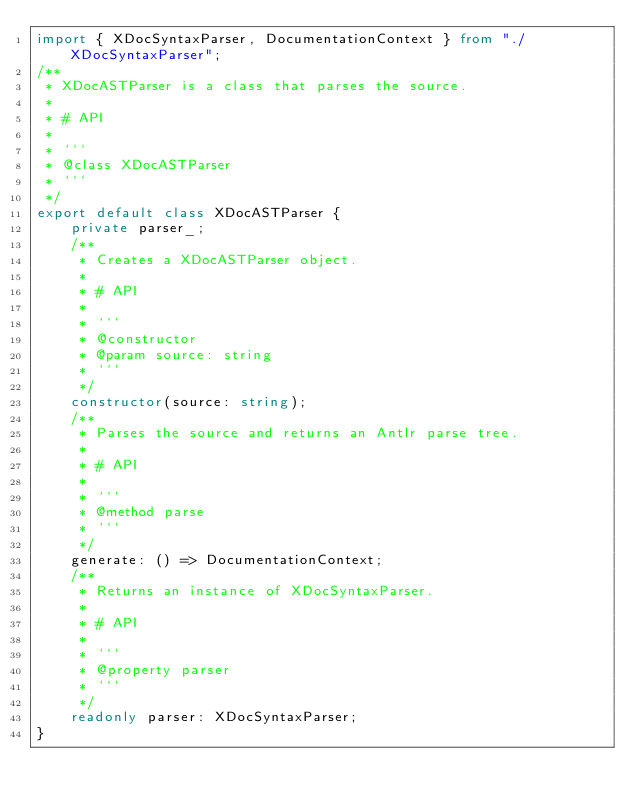<code> <loc_0><loc_0><loc_500><loc_500><_TypeScript_>import { XDocSyntaxParser, DocumentationContext } from "./XDocSyntaxParser";
/**
 * XDocASTParser is a class that parses the source.
 *
 * # API
 *
 * ```
 * @class XDocASTParser
 * ```
 */
export default class XDocASTParser {
    private parser_;
    /**
     * Creates a XDocASTParser object.
     *
     * # API
     *
     * ```
     * @constructor
     * @param source: string
     * ```
     */
    constructor(source: string);
    /**
     * Parses the source and returns an Antlr parse tree.
     *
     * # API
     *
     * ```
     * @method parse
     * ```
     */
    generate: () => DocumentationContext;
    /**
     * Returns an instance of XDocSyntaxParser.
     *
     * # API
     *
     * ```
     * @property parser
     * ```
     */
    readonly parser: XDocSyntaxParser;
}
</code> 